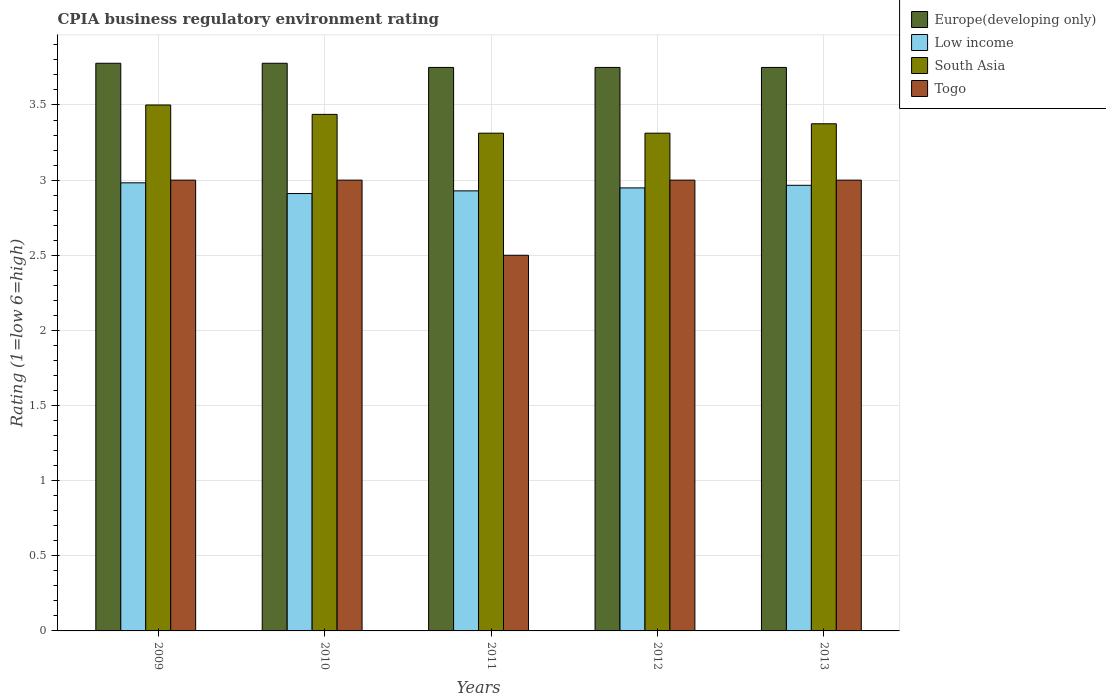How many different coloured bars are there?
Your answer should be very brief. 4. How many groups of bars are there?
Provide a succinct answer. 5. Are the number of bars per tick equal to the number of legend labels?
Your answer should be very brief. Yes. How many bars are there on the 2nd tick from the left?
Your answer should be compact. 4. In how many cases, is the number of bars for a given year not equal to the number of legend labels?
Provide a short and direct response. 0. What is the CPIA rating in Togo in 2010?
Give a very brief answer. 3. Across all years, what is the minimum CPIA rating in Europe(developing only)?
Provide a short and direct response. 3.75. In which year was the CPIA rating in South Asia minimum?
Make the answer very short. 2011. What is the total CPIA rating in Togo in the graph?
Keep it short and to the point. 14.5. What is the difference between the CPIA rating in Togo in 2010 and the CPIA rating in Europe(developing only) in 2013?
Offer a very short reply. -0.75. What is the average CPIA rating in South Asia per year?
Offer a very short reply. 3.39. In the year 2009, what is the difference between the CPIA rating in Europe(developing only) and CPIA rating in Low income?
Provide a short and direct response. 0.8. In how many years, is the CPIA rating in Europe(developing only) greater than 2.9?
Keep it short and to the point. 5. What is the ratio of the CPIA rating in Europe(developing only) in 2009 to that in 2012?
Keep it short and to the point. 1.01. What is the difference between the highest and the second highest CPIA rating in Togo?
Make the answer very short. 0. What is the difference between the highest and the lowest CPIA rating in Low income?
Keep it short and to the point. 0.07. Is it the case that in every year, the sum of the CPIA rating in South Asia and CPIA rating in Europe(developing only) is greater than the sum of CPIA rating in Togo and CPIA rating in Low income?
Keep it short and to the point. Yes. What does the 4th bar from the left in 2013 represents?
Give a very brief answer. Togo. What does the 3rd bar from the right in 2013 represents?
Your response must be concise. Low income. Is it the case that in every year, the sum of the CPIA rating in Europe(developing only) and CPIA rating in Togo is greater than the CPIA rating in South Asia?
Your answer should be very brief. Yes. How many bars are there?
Make the answer very short. 20. Are all the bars in the graph horizontal?
Provide a short and direct response. No. Are the values on the major ticks of Y-axis written in scientific E-notation?
Ensure brevity in your answer.  No. Does the graph contain any zero values?
Your answer should be very brief. No. Does the graph contain grids?
Ensure brevity in your answer.  Yes. How many legend labels are there?
Provide a short and direct response. 4. How are the legend labels stacked?
Provide a short and direct response. Vertical. What is the title of the graph?
Offer a terse response. CPIA business regulatory environment rating. Does "West Bank and Gaza" appear as one of the legend labels in the graph?
Offer a terse response. No. What is the label or title of the X-axis?
Your answer should be very brief. Years. What is the label or title of the Y-axis?
Offer a terse response. Rating (1=low 6=high). What is the Rating (1=low 6=high) of Europe(developing only) in 2009?
Your answer should be compact. 3.78. What is the Rating (1=low 6=high) of Low income in 2009?
Provide a succinct answer. 2.98. What is the Rating (1=low 6=high) in South Asia in 2009?
Offer a terse response. 3.5. What is the Rating (1=low 6=high) of Togo in 2009?
Your answer should be compact. 3. What is the Rating (1=low 6=high) of Europe(developing only) in 2010?
Provide a short and direct response. 3.78. What is the Rating (1=low 6=high) of Low income in 2010?
Your answer should be compact. 2.91. What is the Rating (1=low 6=high) in South Asia in 2010?
Your response must be concise. 3.44. What is the Rating (1=low 6=high) of Togo in 2010?
Your answer should be very brief. 3. What is the Rating (1=low 6=high) in Europe(developing only) in 2011?
Offer a terse response. 3.75. What is the Rating (1=low 6=high) in Low income in 2011?
Provide a succinct answer. 2.93. What is the Rating (1=low 6=high) of South Asia in 2011?
Provide a short and direct response. 3.31. What is the Rating (1=low 6=high) in Europe(developing only) in 2012?
Offer a very short reply. 3.75. What is the Rating (1=low 6=high) in Low income in 2012?
Make the answer very short. 2.95. What is the Rating (1=low 6=high) in South Asia in 2012?
Your answer should be compact. 3.31. What is the Rating (1=low 6=high) in Togo in 2012?
Ensure brevity in your answer.  3. What is the Rating (1=low 6=high) of Europe(developing only) in 2013?
Offer a terse response. 3.75. What is the Rating (1=low 6=high) in Low income in 2013?
Your answer should be very brief. 2.97. What is the Rating (1=low 6=high) in South Asia in 2013?
Your response must be concise. 3.38. Across all years, what is the maximum Rating (1=low 6=high) in Europe(developing only)?
Ensure brevity in your answer.  3.78. Across all years, what is the maximum Rating (1=low 6=high) of Low income?
Your answer should be very brief. 2.98. Across all years, what is the maximum Rating (1=low 6=high) of South Asia?
Your answer should be very brief. 3.5. Across all years, what is the maximum Rating (1=low 6=high) in Togo?
Your answer should be very brief. 3. Across all years, what is the minimum Rating (1=low 6=high) in Europe(developing only)?
Your response must be concise. 3.75. Across all years, what is the minimum Rating (1=low 6=high) in Low income?
Offer a very short reply. 2.91. Across all years, what is the minimum Rating (1=low 6=high) in South Asia?
Give a very brief answer. 3.31. Across all years, what is the minimum Rating (1=low 6=high) in Togo?
Offer a very short reply. 2.5. What is the total Rating (1=low 6=high) in Europe(developing only) in the graph?
Your answer should be very brief. 18.81. What is the total Rating (1=low 6=high) of Low income in the graph?
Ensure brevity in your answer.  14.74. What is the total Rating (1=low 6=high) in South Asia in the graph?
Offer a very short reply. 16.94. What is the difference between the Rating (1=low 6=high) of Europe(developing only) in 2009 and that in 2010?
Provide a short and direct response. 0. What is the difference between the Rating (1=low 6=high) in Low income in 2009 and that in 2010?
Your answer should be very brief. 0.07. What is the difference between the Rating (1=low 6=high) of South Asia in 2009 and that in 2010?
Your answer should be compact. 0.06. What is the difference between the Rating (1=low 6=high) of Europe(developing only) in 2009 and that in 2011?
Give a very brief answer. 0.03. What is the difference between the Rating (1=low 6=high) in Low income in 2009 and that in 2011?
Keep it short and to the point. 0.05. What is the difference between the Rating (1=low 6=high) of South Asia in 2009 and that in 2011?
Offer a terse response. 0.19. What is the difference between the Rating (1=low 6=high) in Togo in 2009 and that in 2011?
Ensure brevity in your answer.  0.5. What is the difference between the Rating (1=low 6=high) in Europe(developing only) in 2009 and that in 2012?
Your answer should be very brief. 0.03. What is the difference between the Rating (1=low 6=high) of Low income in 2009 and that in 2012?
Provide a succinct answer. 0.03. What is the difference between the Rating (1=low 6=high) in South Asia in 2009 and that in 2012?
Your answer should be compact. 0.19. What is the difference between the Rating (1=low 6=high) of Togo in 2009 and that in 2012?
Keep it short and to the point. 0. What is the difference between the Rating (1=low 6=high) of Europe(developing only) in 2009 and that in 2013?
Your answer should be compact. 0.03. What is the difference between the Rating (1=low 6=high) in Low income in 2009 and that in 2013?
Provide a succinct answer. 0.02. What is the difference between the Rating (1=low 6=high) of Europe(developing only) in 2010 and that in 2011?
Offer a very short reply. 0.03. What is the difference between the Rating (1=low 6=high) in Low income in 2010 and that in 2011?
Your answer should be compact. -0.02. What is the difference between the Rating (1=low 6=high) of South Asia in 2010 and that in 2011?
Provide a short and direct response. 0.12. What is the difference between the Rating (1=low 6=high) of Europe(developing only) in 2010 and that in 2012?
Keep it short and to the point. 0.03. What is the difference between the Rating (1=low 6=high) of Low income in 2010 and that in 2012?
Your answer should be very brief. -0.04. What is the difference between the Rating (1=low 6=high) in South Asia in 2010 and that in 2012?
Provide a succinct answer. 0.12. What is the difference between the Rating (1=low 6=high) of Europe(developing only) in 2010 and that in 2013?
Offer a very short reply. 0.03. What is the difference between the Rating (1=low 6=high) of Low income in 2010 and that in 2013?
Your answer should be compact. -0.05. What is the difference between the Rating (1=low 6=high) in South Asia in 2010 and that in 2013?
Your answer should be very brief. 0.06. What is the difference between the Rating (1=low 6=high) in Togo in 2010 and that in 2013?
Make the answer very short. 0. What is the difference between the Rating (1=low 6=high) in Europe(developing only) in 2011 and that in 2012?
Your answer should be very brief. 0. What is the difference between the Rating (1=low 6=high) in Low income in 2011 and that in 2012?
Provide a succinct answer. -0.02. What is the difference between the Rating (1=low 6=high) in South Asia in 2011 and that in 2012?
Keep it short and to the point. 0. What is the difference between the Rating (1=low 6=high) of Low income in 2011 and that in 2013?
Offer a terse response. -0.04. What is the difference between the Rating (1=low 6=high) of South Asia in 2011 and that in 2013?
Keep it short and to the point. -0.06. What is the difference between the Rating (1=low 6=high) in Togo in 2011 and that in 2013?
Provide a succinct answer. -0.5. What is the difference between the Rating (1=low 6=high) of Low income in 2012 and that in 2013?
Provide a succinct answer. -0.02. What is the difference between the Rating (1=low 6=high) in South Asia in 2012 and that in 2013?
Provide a succinct answer. -0.06. What is the difference between the Rating (1=low 6=high) of Europe(developing only) in 2009 and the Rating (1=low 6=high) of Low income in 2010?
Your answer should be very brief. 0.87. What is the difference between the Rating (1=low 6=high) in Europe(developing only) in 2009 and the Rating (1=low 6=high) in South Asia in 2010?
Give a very brief answer. 0.34. What is the difference between the Rating (1=low 6=high) in Europe(developing only) in 2009 and the Rating (1=low 6=high) in Togo in 2010?
Your answer should be compact. 0.78. What is the difference between the Rating (1=low 6=high) in Low income in 2009 and the Rating (1=low 6=high) in South Asia in 2010?
Provide a succinct answer. -0.46. What is the difference between the Rating (1=low 6=high) in Low income in 2009 and the Rating (1=low 6=high) in Togo in 2010?
Your response must be concise. -0.02. What is the difference between the Rating (1=low 6=high) in Europe(developing only) in 2009 and the Rating (1=low 6=high) in Low income in 2011?
Your response must be concise. 0.85. What is the difference between the Rating (1=low 6=high) of Europe(developing only) in 2009 and the Rating (1=low 6=high) of South Asia in 2011?
Give a very brief answer. 0.47. What is the difference between the Rating (1=low 6=high) of Europe(developing only) in 2009 and the Rating (1=low 6=high) of Togo in 2011?
Keep it short and to the point. 1.28. What is the difference between the Rating (1=low 6=high) of Low income in 2009 and the Rating (1=low 6=high) of South Asia in 2011?
Make the answer very short. -0.33. What is the difference between the Rating (1=low 6=high) of Low income in 2009 and the Rating (1=low 6=high) of Togo in 2011?
Make the answer very short. 0.48. What is the difference between the Rating (1=low 6=high) of Europe(developing only) in 2009 and the Rating (1=low 6=high) of Low income in 2012?
Make the answer very short. 0.83. What is the difference between the Rating (1=low 6=high) in Europe(developing only) in 2009 and the Rating (1=low 6=high) in South Asia in 2012?
Ensure brevity in your answer.  0.47. What is the difference between the Rating (1=low 6=high) in Low income in 2009 and the Rating (1=low 6=high) in South Asia in 2012?
Give a very brief answer. -0.33. What is the difference between the Rating (1=low 6=high) of Low income in 2009 and the Rating (1=low 6=high) of Togo in 2012?
Provide a succinct answer. -0.02. What is the difference between the Rating (1=low 6=high) in South Asia in 2009 and the Rating (1=low 6=high) in Togo in 2012?
Keep it short and to the point. 0.5. What is the difference between the Rating (1=low 6=high) of Europe(developing only) in 2009 and the Rating (1=low 6=high) of Low income in 2013?
Make the answer very short. 0.81. What is the difference between the Rating (1=low 6=high) of Europe(developing only) in 2009 and the Rating (1=low 6=high) of South Asia in 2013?
Ensure brevity in your answer.  0.4. What is the difference between the Rating (1=low 6=high) in Low income in 2009 and the Rating (1=low 6=high) in South Asia in 2013?
Keep it short and to the point. -0.39. What is the difference between the Rating (1=low 6=high) in Low income in 2009 and the Rating (1=low 6=high) in Togo in 2013?
Give a very brief answer. -0.02. What is the difference between the Rating (1=low 6=high) in Europe(developing only) in 2010 and the Rating (1=low 6=high) in Low income in 2011?
Keep it short and to the point. 0.85. What is the difference between the Rating (1=low 6=high) in Europe(developing only) in 2010 and the Rating (1=low 6=high) in South Asia in 2011?
Ensure brevity in your answer.  0.47. What is the difference between the Rating (1=low 6=high) of Europe(developing only) in 2010 and the Rating (1=low 6=high) of Togo in 2011?
Provide a succinct answer. 1.28. What is the difference between the Rating (1=low 6=high) of Low income in 2010 and the Rating (1=low 6=high) of South Asia in 2011?
Ensure brevity in your answer.  -0.4. What is the difference between the Rating (1=low 6=high) in Low income in 2010 and the Rating (1=low 6=high) in Togo in 2011?
Your answer should be very brief. 0.41. What is the difference between the Rating (1=low 6=high) of Europe(developing only) in 2010 and the Rating (1=low 6=high) of Low income in 2012?
Offer a terse response. 0.83. What is the difference between the Rating (1=low 6=high) in Europe(developing only) in 2010 and the Rating (1=low 6=high) in South Asia in 2012?
Provide a short and direct response. 0.47. What is the difference between the Rating (1=low 6=high) in Europe(developing only) in 2010 and the Rating (1=low 6=high) in Togo in 2012?
Offer a terse response. 0.78. What is the difference between the Rating (1=low 6=high) of Low income in 2010 and the Rating (1=low 6=high) of South Asia in 2012?
Keep it short and to the point. -0.4. What is the difference between the Rating (1=low 6=high) of Low income in 2010 and the Rating (1=low 6=high) of Togo in 2012?
Make the answer very short. -0.09. What is the difference between the Rating (1=low 6=high) in South Asia in 2010 and the Rating (1=low 6=high) in Togo in 2012?
Your answer should be very brief. 0.44. What is the difference between the Rating (1=low 6=high) in Europe(developing only) in 2010 and the Rating (1=low 6=high) in Low income in 2013?
Make the answer very short. 0.81. What is the difference between the Rating (1=low 6=high) in Europe(developing only) in 2010 and the Rating (1=low 6=high) in South Asia in 2013?
Offer a terse response. 0.4. What is the difference between the Rating (1=low 6=high) of Low income in 2010 and the Rating (1=low 6=high) of South Asia in 2013?
Offer a terse response. -0.46. What is the difference between the Rating (1=low 6=high) in Low income in 2010 and the Rating (1=low 6=high) in Togo in 2013?
Your answer should be compact. -0.09. What is the difference between the Rating (1=low 6=high) in South Asia in 2010 and the Rating (1=low 6=high) in Togo in 2013?
Provide a short and direct response. 0.44. What is the difference between the Rating (1=low 6=high) in Europe(developing only) in 2011 and the Rating (1=low 6=high) in Low income in 2012?
Keep it short and to the point. 0.8. What is the difference between the Rating (1=low 6=high) in Europe(developing only) in 2011 and the Rating (1=low 6=high) in South Asia in 2012?
Offer a terse response. 0.44. What is the difference between the Rating (1=low 6=high) of Europe(developing only) in 2011 and the Rating (1=low 6=high) of Togo in 2012?
Give a very brief answer. 0.75. What is the difference between the Rating (1=low 6=high) of Low income in 2011 and the Rating (1=low 6=high) of South Asia in 2012?
Offer a very short reply. -0.38. What is the difference between the Rating (1=low 6=high) of Low income in 2011 and the Rating (1=low 6=high) of Togo in 2012?
Provide a short and direct response. -0.07. What is the difference between the Rating (1=low 6=high) of South Asia in 2011 and the Rating (1=low 6=high) of Togo in 2012?
Ensure brevity in your answer.  0.31. What is the difference between the Rating (1=low 6=high) in Europe(developing only) in 2011 and the Rating (1=low 6=high) in Low income in 2013?
Provide a succinct answer. 0.78. What is the difference between the Rating (1=low 6=high) in Europe(developing only) in 2011 and the Rating (1=low 6=high) in South Asia in 2013?
Make the answer very short. 0.38. What is the difference between the Rating (1=low 6=high) in Europe(developing only) in 2011 and the Rating (1=low 6=high) in Togo in 2013?
Provide a succinct answer. 0.75. What is the difference between the Rating (1=low 6=high) in Low income in 2011 and the Rating (1=low 6=high) in South Asia in 2013?
Your answer should be compact. -0.45. What is the difference between the Rating (1=low 6=high) of Low income in 2011 and the Rating (1=low 6=high) of Togo in 2013?
Offer a very short reply. -0.07. What is the difference between the Rating (1=low 6=high) in South Asia in 2011 and the Rating (1=low 6=high) in Togo in 2013?
Your answer should be very brief. 0.31. What is the difference between the Rating (1=low 6=high) in Europe(developing only) in 2012 and the Rating (1=low 6=high) in Low income in 2013?
Your answer should be compact. 0.78. What is the difference between the Rating (1=low 6=high) in Europe(developing only) in 2012 and the Rating (1=low 6=high) in South Asia in 2013?
Provide a succinct answer. 0.38. What is the difference between the Rating (1=low 6=high) of Europe(developing only) in 2012 and the Rating (1=low 6=high) of Togo in 2013?
Give a very brief answer. 0.75. What is the difference between the Rating (1=low 6=high) in Low income in 2012 and the Rating (1=low 6=high) in South Asia in 2013?
Keep it short and to the point. -0.43. What is the difference between the Rating (1=low 6=high) in Low income in 2012 and the Rating (1=low 6=high) in Togo in 2013?
Your answer should be compact. -0.05. What is the difference between the Rating (1=low 6=high) of South Asia in 2012 and the Rating (1=low 6=high) of Togo in 2013?
Your answer should be compact. 0.31. What is the average Rating (1=low 6=high) of Europe(developing only) per year?
Offer a terse response. 3.76. What is the average Rating (1=low 6=high) of Low income per year?
Ensure brevity in your answer.  2.95. What is the average Rating (1=low 6=high) in South Asia per year?
Ensure brevity in your answer.  3.39. In the year 2009, what is the difference between the Rating (1=low 6=high) of Europe(developing only) and Rating (1=low 6=high) of Low income?
Offer a terse response. 0.8. In the year 2009, what is the difference between the Rating (1=low 6=high) in Europe(developing only) and Rating (1=low 6=high) in South Asia?
Offer a terse response. 0.28. In the year 2009, what is the difference between the Rating (1=low 6=high) in Europe(developing only) and Rating (1=low 6=high) in Togo?
Your answer should be very brief. 0.78. In the year 2009, what is the difference between the Rating (1=low 6=high) in Low income and Rating (1=low 6=high) in South Asia?
Your response must be concise. -0.52. In the year 2009, what is the difference between the Rating (1=low 6=high) of Low income and Rating (1=low 6=high) of Togo?
Provide a succinct answer. -0.02. In the year 2009, what is the difference between the Rating (1=low 6=high) in South Asia and Rating (1=low 6=high) in Togo?
Offer a very short reply. 0.5. In the year 2010, what is the difference between the Rating (1=low 6=high) in Europe(developing only) and Rating (1=low 6=high) in Low income?
Your response must be concise. 0.87. In the year 2010, what is the difference between the Rating (1=low 6=high) of Europe(developing only) and Rating (1=low 6=high) of South Asia?
Your response must be concise. 0.34. In the year 2010, what is the difference between the Rating (1=low 6=high) of Europe(developing only) and Rating (1=low 6=high) of Togo?
Your response must be concise. 0.78. In the year 2010, what is the difference between the Rating (1=low 6=high) of Low income and Rating (1=low 6=high) of South Asia?
Give a very brief answer. -0.53. In the year 2010, what is the difference between the Rating (1=low 6=high) of Low income and Rating (1=low 6=high) of Togo?
Give a very brief answer. -0.09. In the year 2010, what is the difference between the Rating (1=low 6=high) in South Asia and Rating (1=low 6=high) in Togo?
Your answer should be very brief. 0.44. In the year 2011, what is the difference between the Rating (1=low 6=high) in Europe(developing only) and Rating (1=low 6=high) in Low income?
Make the answer very short. 0.82. In the year 2011, what is the difference between the Rating (1=low 6=high) in Europe(developing only) and Rating (1=low 6=high) in South Asia?
Ensure brevity in your answer.  0.44. In the year 2011, what is the difference between the Rating (1=low 6=high) in Europe(developing only) and Rating (1=low 6=high) in Togo?
Provide a succinct answer. 1.25. In the year 2011, what is the difference between the Rating (1=low 6=high) in Low income and Rating (1=low 6=high) in South Asia?
Provide a short and direct response. -0.38. In the year 2011, what is the difference between the Rating (1=low 6=high) in Low income and Rating (1=low 6=high) in Togo?
Make the answer very short. 0.43. In the year 2011, what is the difference between the Rating (1=low 6=high) in South Asia and Rating (1=low 6=high) in Togo?
Give a very brief answer. 0.81. In the year 2012, what is the difference between the Rating (1=low 6=high) of Europe(developing only) and Rating (1=low 6=high) of Low income?
Your answer should be very brief. 0.8. In the year 2012, what is the difference between the Rating (1=low 6=high) of Europe(developing only) and Rating (1=low 6=high) of South Asia?
Give a very brief answer. 0.44. In the year 2012, what is the difference between the Rating (1=low 6=high) of Europe(developing only) and Rating (1=low 6=high) of Togo?
Ensure brevity in your answer.  0.75. In the year 2012, what is the difference between the Rating (1=low 6=high) of Low income and Rating (1=low 6=high) of South Asia?
Make the answer very short. -0.36. In the year 2012, what is the difference between the Rating (1=low 6=high) in Low income and Rating (1=low 6=high) in Togo?
Keep it short and to the point. -0.05. In the year 2012, what is the difference between the Rating (1=low 6=high) of South Asia and Rating (1=low 6=high) of Togo?
Your response must be concise. 0.31. In the year 2013, what is the difference between the Rating (1=low 6=high) in Europe(developing only) and Rating (1=low 6=high) in Low income?
Offer a very short reply. 0.78. In the year 2013, what is the difference between the Rating (1=low 6=high) of Europe(developing only) and Rating (1=low 6=high) of Togo?
Provide a short and direct response. 0.75. In the year 2013, what is the difference between the Rating (1=low 6=high) of Low income and Rating (1=low 6=high) of South Asia?
Offer a very short reply. -0.41. In the year 2013, what is the difference between the Rating (1=low 6=high) of Low income and Rating (1=low 6=high) of Togo?
Offer a terse response. -0.03. In the year 2013, what is the difference between the Rating (1=low 6=high) in South Asia and Rating (1=low 6=high) in Togo?
Provide a succinct answer. 0.38. What is the ratio of the Rating (1=low 6=high) of Low income in 2009 to that in 2010?
Provide a short and direct response. 1.02. What is the ratio of the Rating (1=low 6=high) of South Asia in 2009 to that in 2010?
Keep it short and to the point. 1.02. What is the ratio of the Rating (1=low 6=high) in Togo in 2009 to that in 2010?
Offer a terse response. 1. What is the ratio of the Rating (1=low 6=high) in Europe(developing only) in 2009 to that in 2011?
Give a very brief answer. 1.01. What is the ratio of the Rating (1=low 6=high) of Low income in 2009 to that in 2011?
Give a very brief answer. 1.02. What is the ratio of the Rating (1=low 6=high) in South Asia in 2009 to that in 2011?
Your answer should be compact. 1.06. What is the ratio of the Rating (1=low 6=high) of Togo in 2009 to that in 2011?
Offer a terse response. 1.2. What is the ratio of the Rating (1=low 6=high) of Europe(developing only) in 2009 to that in 2012?
Provide a short and direct response. 1.01. What is the ratio of the Rating (1=low 6=high) in Low income in 2009 to that in 2012?
Your response must be concise. 1.01. What is the ratio of the Rating (1=low 6=high) of South Asia in 2009 to that in 2012?
Provide a succinct answer. 1.06. What is the ratio of the Rating (1=low 6=high) of Europe(developing only) in 2009 to that in 2013?
Provide a succinct answer. 1.01. What is the ratio of the Rating (1=low 6=high) of Low income in 2009 to that in 2013?
Give a very brief answer. 1.01. What is the ratio of the Rating (1=low 6=high) in South Asia in 2009 to that in 2013?
Provide a short and direct response. 1.04. What is the ratio of the Rating (1=low 6=high) in Togo in 2009 to that in 2013?
Offer a terse response. 1. What is the ratio of the Rating (1=low 6=high) of Europe(developing only) in 2010 to that in 2011?
Make the answer very short. 1.01. What is the ratio of the Rating (1=low 6=high) in Low income in 2010 to that in 2011?
Your answer should be compact. 0.99. What is the ratio of the Rating (1=low 6=high) in South Asia in 2010 to that in 2011?
Provide a short and direct response. 1.04. What is the ratio of the Rating (1=low 6=high) of Togo in 2010 to that in 2011?
Ensure brevity in your answer.  1.2. What is the ratio of the Rating (1=low 6=high) in Europe(developing only) in 2010 to that in 2012?
Provide a succinct answer. 1.01. What is the ratio of the Rating (1=low 6=high) of Low income in 2010 to that in 2012?
Your response must be concise. 0.99. What is the ratio of the Rating (1=low 6=high) in South Asia in 2010 to that in 2012?
Give a very brief answer. 1.04. What is the ratio of the Rating (1=low 6=high) of Togo in 2010 to that in 2012?
Provide a succinct answer. 1. What is the ratio of the Rating (1=low 6=high) of Europe(developing only) in 2010 to that in 2013?
Give a very brief answer. 1.01. What is the ratio of the Rating (1=low 6=high) in Low income in 2010 to that in 2013?
Keep it short and to the point. 0.98. What is the ratio of the Rating (1=low 6=high) of South Asia in 2010 to that in 2013?
Provide a succinct answer. 1.02. What is the ratio of the Rating (1=low 6=high) in Europe(developing only) in 2011 to that in 2012?
Provide a succinct answer. 1. What is the ratio of the Rating (1=low 6=high) in Low income in 2011 to that in 2012?
Your response must be concise. 0.99. What is the ratio of the Rating (1=low 6=high) in Togo in 2011 to that in 2012?
Your response must be concise. 0.83. What is the ratio of the Rating (1=low 6=high) in Europe(developing only) in 2011 to that in 2013?
Offer a terse response. 1. What is the ratio of the Rating (1=low 6=high) of Low income in 2011 to that in 2013?
Offer a terse response. 0.99. What is the ratio of the Rating (1=low 6=high) of South Asia in 2011 to that in 2013?
Your response must be concise. 0.98. What is the ratio of the Rating (1=low 6=high) in Togo in 2011 to that in 2013?
Provide a succinct answer. 0.83. What is the ratio of the Rating (1=low 6=high) of Low income in 2012 to that in 2013?
Make the answer very short. 0.99. What is the ratio of the Rating (1=low 6=high) in South Asia in 2012 to that in 2013?
Your answer should be compact. 0.98. What is the difference between the highest and the second highest Rating (1=low 6=high) of Europe(developing only)?
Your answer should be very brief. 0. What is the difference between the highest and the second highest Rating (1=low 6=high) of Low income?
Offer a very short reply. 0.02. What is the difference between the highest and the second highest Rating (1=low 6=high) in South Asia?
Your answer should be very brief. 0.06. What is the difference between the highest and the lowest Rating (1=low 6=high) of Europe(developing only)?
Offer a very short reply. 0.03. What is the difference between the highest and the lowest Rating (1=low 6=high) of Low income?
Give a very brief answer. 0.07. What is the difference between the highest and the lowest Rating (1=low 6=high) in South Asia?
Offer a terse response. 0.19. What is the difference between the highest and the lowest Rating (1=low 6=high) in Togo?
Your answer should be compact. 0.5. 